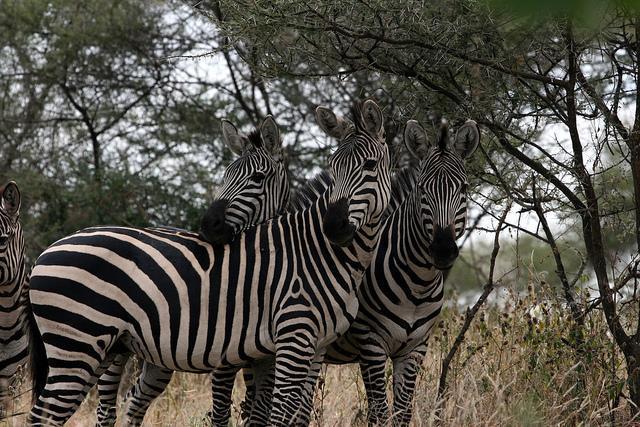How many zebras are there?
Give a very brief answer. 4. How many zebras are in the picture?
Give a very brief answer. 3. How many zebras?
Give a very brief answer. 4. How many animals are in the pic?
Give a very brief answer. 4. How many adult animals can be seen?
Give a very brief answer. 3. 